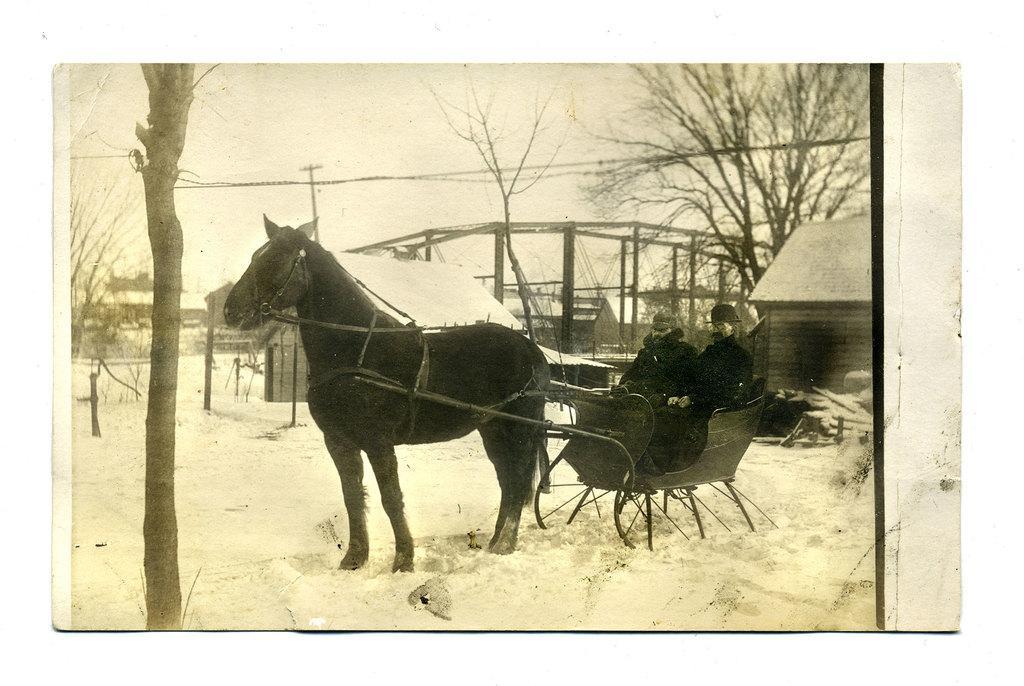Could you give a brief overview of what you see in this image? This is an old black and white picture. I can see snow, horse, there are two persons sitting on the horse cart, there are houses, trees, and in the background there is sky. 